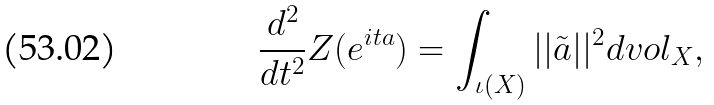<formula> <loc_0><loc_0><loc_500><loc_500>\frac { d ^ { 2 } } { d t ^ { 2 } } Z ( e ^ { i t a } ) = \int _ { \iota ( X ) } | | \tilde { a } | | ^ { 2 } d v o l _ { X } ,</formula> 